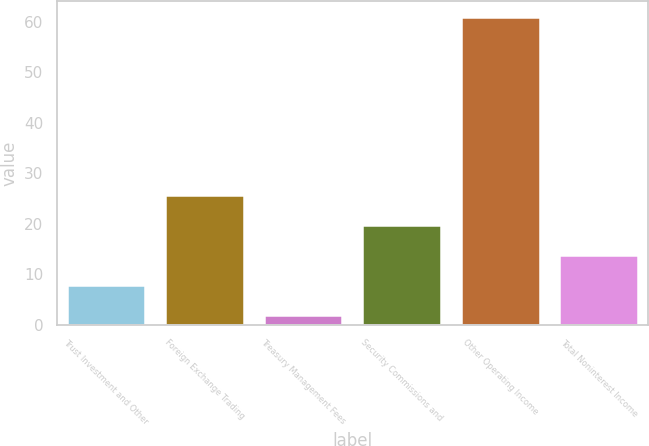Convert chart. <chart><loc_0><loc_0><loc_500><loc_500><bar_chart><fcel>Trust Investment and Other<fcel>Foreign Exchange Trading<fcel>Treasury Management Fees<fcel>Security Commissions and<fcel>Other Operating Income<fcel>Total Noninterest Income<nl><fcel>7.9<fcel>25.6<fcel>2<fcel>19.7<fcel>61<fcel>13.8<nl></chart> 